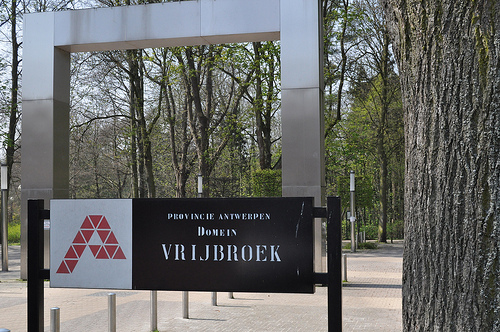<image>
Can you confirm if the pole is behind the sign? Yes. From this viewpoint, the pole is positioned behind the sign, with the sign partially or fully occluding the pole. 